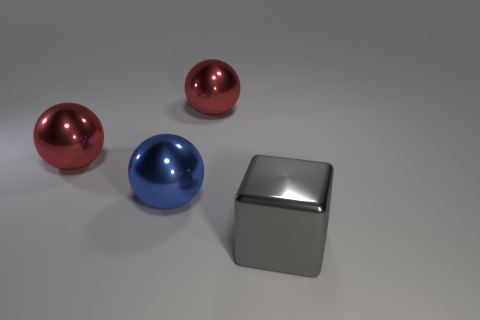Add 3 yellow blocks. How many objects exist? 7 Subtract all spheres. How many objects are left? 1 Subtract all big blue shiny balls. Subtract all large blue metal things. How many objects are left? 2 Add 1 big red metal spheres. How many big red metal spheres are left? 3 Add 2 small brown matte cylinders. How many small brown matte cylinders exist? 2 Subtract 1 gray blocks. How many objects are left? 3 